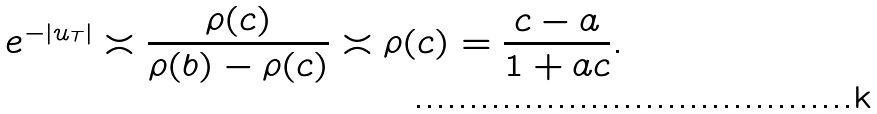<formula> <loc_0><loc_0><loc_500><loc_500>e ^ { - \left | u _ { T } \right | } \asymp \frac { \rho ( c ) } { \rho ( b ) - \rho ( c ) } \asymp \rho ( c ) = \frac { c - a } { 1 + a c } .</formula> 